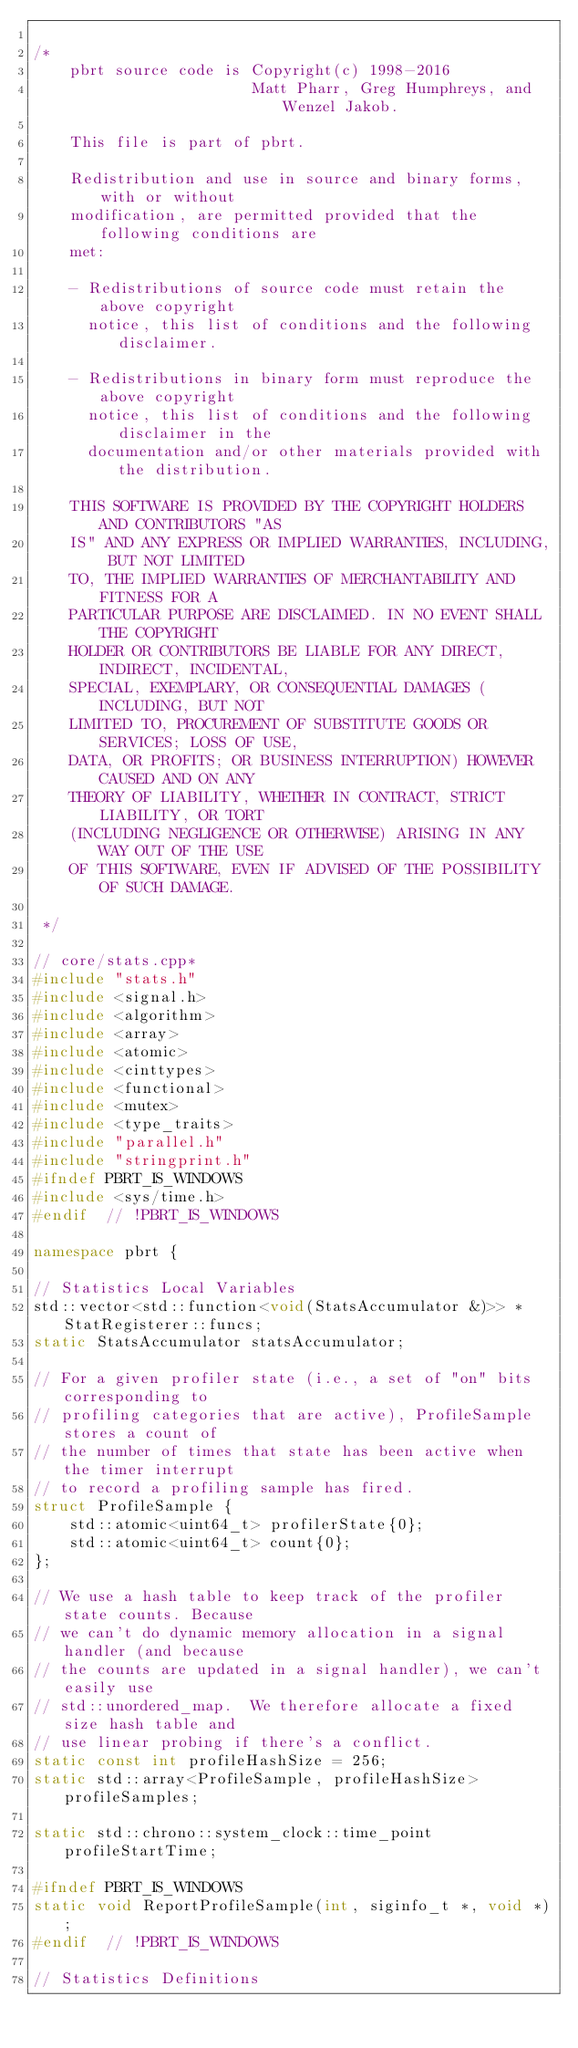<code> <loc_0><loc_0><loc_500><loc_500><_C++_>
/*
    pbrt source code is Copyright(c) 1998-2016
                        Matt Pharr, Greg Humphreys, and Wenzel Jakob.

    This file is part of pbrt.

    Redistribution and use in source and binary forms, with or without
    modification, are permitted provided that the following conditions are
    met:

    - Redistributions of source code must retain the above copyright
      notice, this list of conditions and the following disclaimer.

    - Redistributions in binary form must reproduce the above copyright
      notice, this list of conditions and the following disclaimer in the
      documentation and/or other materials provided with the distribution.

    THIS SOFTWARE IS PROVIDED BY THE COPYRIGHT HOLDERS AND CONTRIBUTORS "AS
    IS" AND ANY EXPRESS OR IMPLIED WARRANTIES, INCLUDING, BUT NOT LIMITED
    TO, THE IMPLIED WARRANTIES OF MERCHANTABILITY AND FITNESS FOR A
    PARTICULAR PURPOSE ARE DISCLAIMED. IN NO EVENT SHALL THE COPYRIGHT
    HOLDER OR CONTRIBUTORS BE LIABLE FOR ANY DIRECT, INDIRECT, INCIDENTAL,
    SPECIAL, EXEMPLARY, OR CONSEQUENTIAL DAMAGES (INCLUDING, BUT NOT
    LIMITED TO, PROCUREMENT OF SUBSTITUTE GOODS OR SERVICES; LOSS OF USE,
    DATA, OR PROFITS; OR BUSINESS INTERRUPTION) HOWEVER CAUSED AND ON ANY
    THEORY OF LIABILITY, WHETHER IN CONTRACT, STRICT LIABILITY, OR TORT
    (INCLUDING NEGLIGENCE OR OTHERWISE) ARISING IN ANY WAY OUT OF THE USE
    OF THIS SOFTWARE, EVEN IF ADVISED OF THE POSSIBILITY OF SUCH DAMAGE.

 */

// core/stats.cpp*
#include "stats.h"
#include <signal.h>
#include <algorithm>
#include <array>
#include <atomic>
#include <cinttypes>
#include <functional>
#include <mutex>
#include <type_traits>
#include "parallel.h"
#include "stringprint.h"
#ifndef PBRT_IS_WINDOWS
#include <sys/time.h>
#endif  // !PBRT_IS_WINDOWS

namespace pbrt {

// Statistics Local Variables
std::vector<std::function<void(StatsAccumulator &)>> *StatRegisterer::funcs;
static StatsAccumulator statsAccumulator;

// For a given profiler state (i.e., a set of "on" bits corresponding to
// profiling categories that are active), ProfileSample stores a count of
// the number of times that state has been active when the timer interrupt
// to record a profiling sample has fired.
struct ProfileSample {
    std::atomic<uint64_t> profilerState{0};
    std::atomic<uint64_t> count{0};
};

// We use a hash table to keep track of the profiler state counts. Because
// we can't do dynamic memory allocation in a signal handler (and because
// the counts are updated in a signal handler), we can't easily use
// std::unordered_map.  We therefore allocate a fixed size hash table and
// use linear probing if there's a conflict.
static const int profileHashSize = 256;
static std::array<ProfileSample, profileHashSize> profileSamples;

static std::chrono::system_clock::time_point profileStartTime;

#ifndef PBRT_IS_WINDOWS
static void ReportProfileSample(int, siginfo_t *, void *);
#endif  // !PBRT_IS_WINDOWS

// Statistics Definitions</code> 